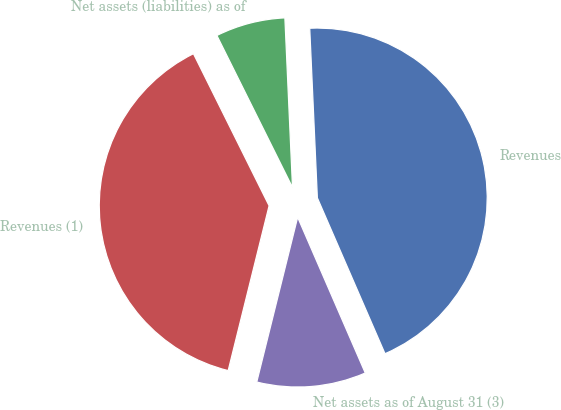Convert chart to OTSL. <chart><loc_0><loc_0><loc_500><loc_500><pie_chart><fcel>Revenues<fcel>Net assets (liabilities) as of<fcel>Revenues (1)<fcel>Net assets as of August 31 (3)<nl><fcel>44.2%<fcel>6.63%<fcel>38.78%<fcel>10.39%<nl></chart> 